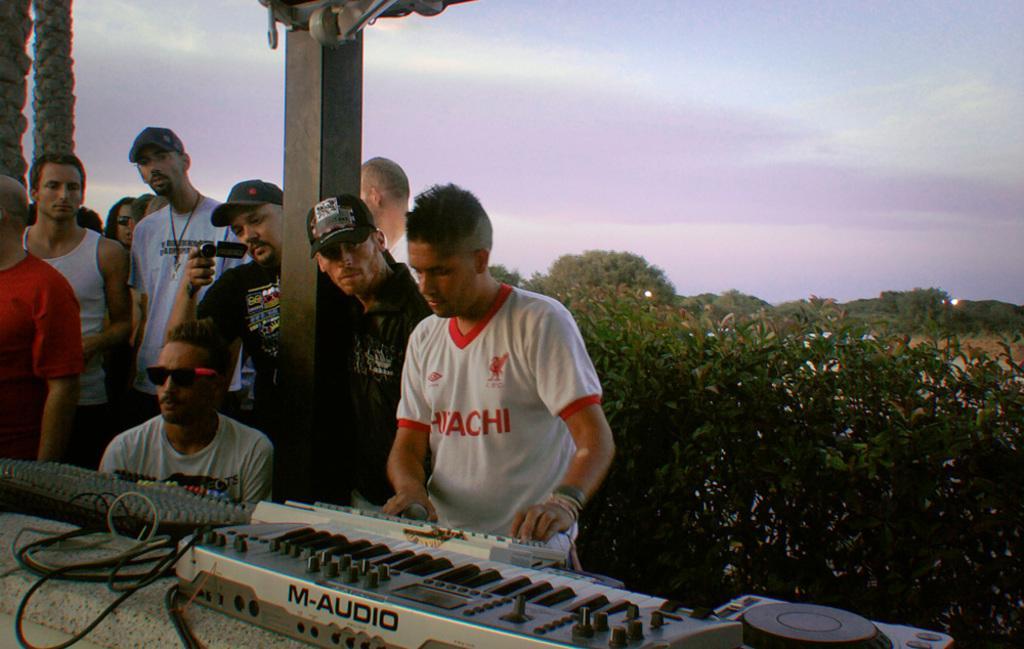Can you describe this image briefly? This image consists of many persons standing. In the front, there is a man playing keyboard. At the bottom, there is a wall on which many instruments are kept. In the background, there are plants and trees. 